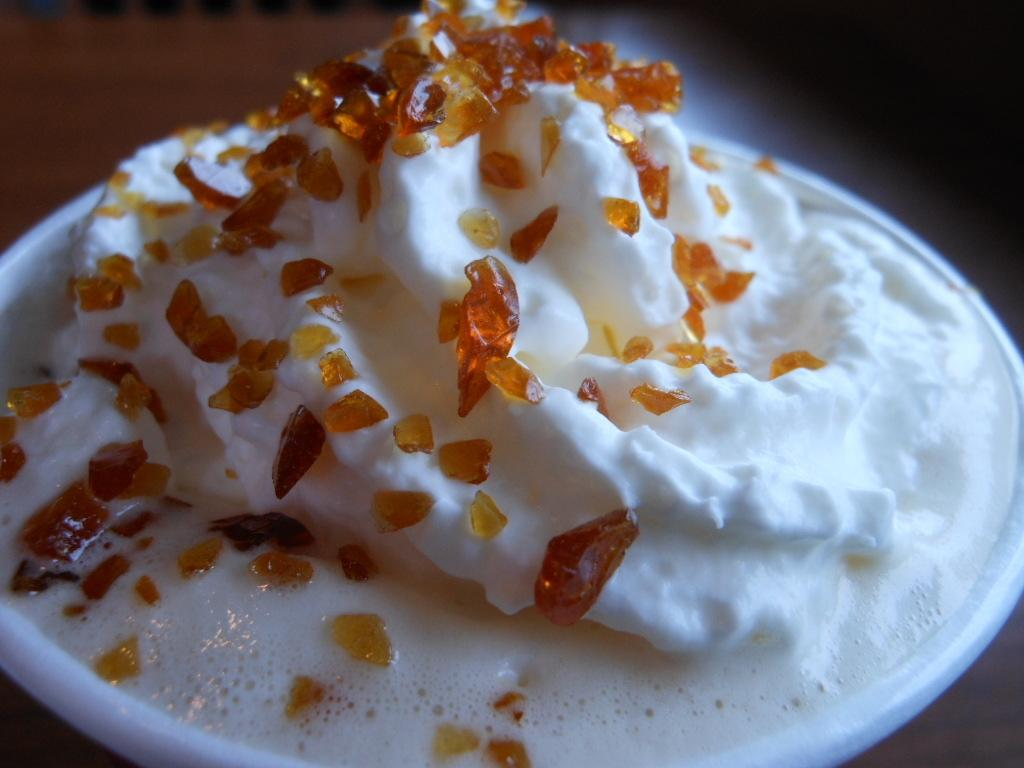What is the main subject of the image? The main subject of the image is a cup of ice cream. Can you describe the appearance of the ice cream? The ice cream is in a cup, but there is no specific information about its flavor or toppings. What can be seen in the background of the image? The background of the image is blurred, so it is difficult to make out any specific details. What page is the watch displayed on in the image? There is no watch or page present in the image; it only features a cup of ice cream and a blurred background. 